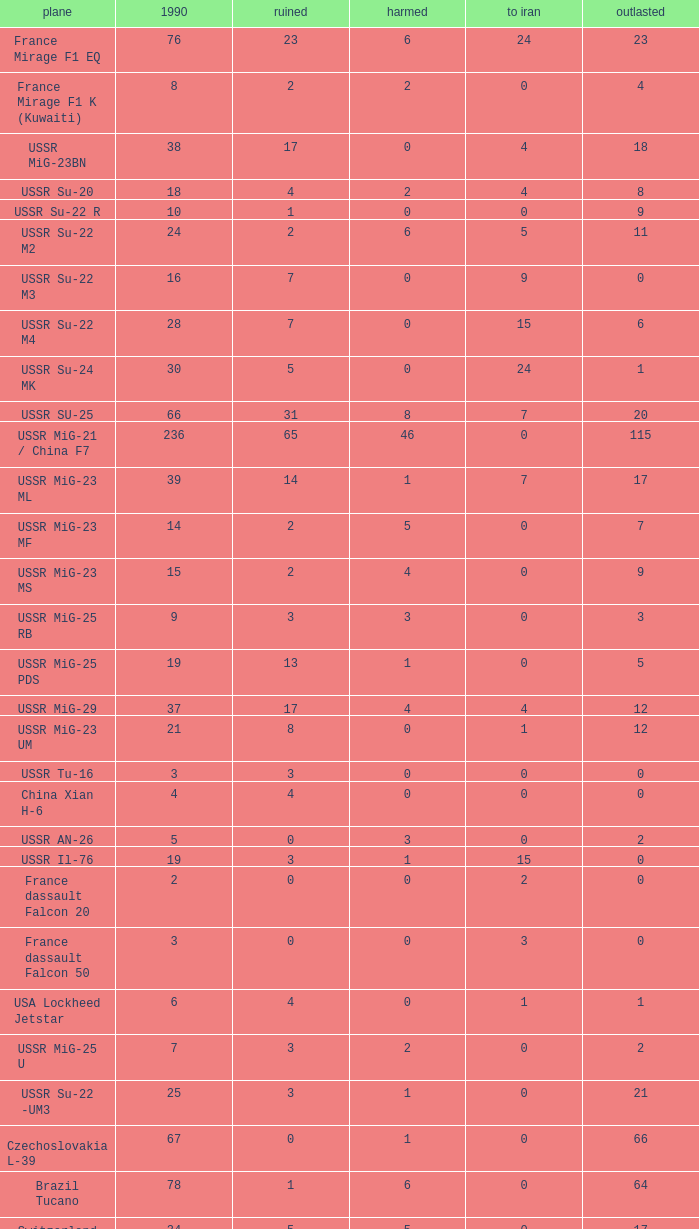If there were 14 in 1990 and 6 survived how many were destroyed? 1.0. 